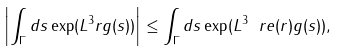<formula> <loc_0><loc_0><loc_500><loc_500>\left | \int _ { \Gamma } d s \exp ( L ^ { 3 } r g ( s ) ) \right | \leq \int _ { \Gamma } d s \exp ( L ^ { 3 } \ r e ( r ) g ( s ) ) ,</formula> 